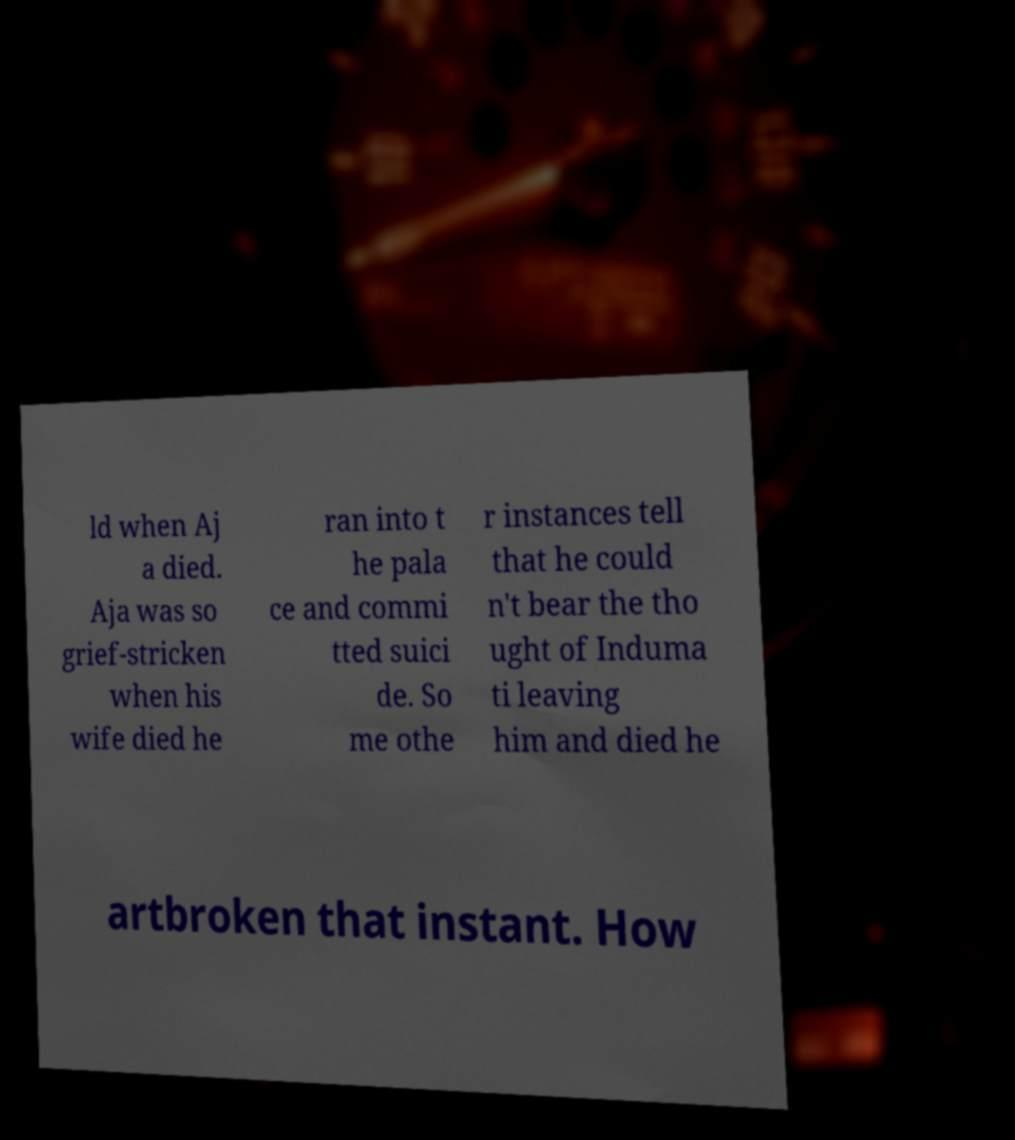Could you extract and type out the text from this image? ld when Aj a died. Aja was so grief-stricken when his wife died he ran into t he pala ce and commi tted suici de. So me othe r instances tell that he could n't bear the tho ught of Induma ti leaving him and died he artbroken that instant. How 